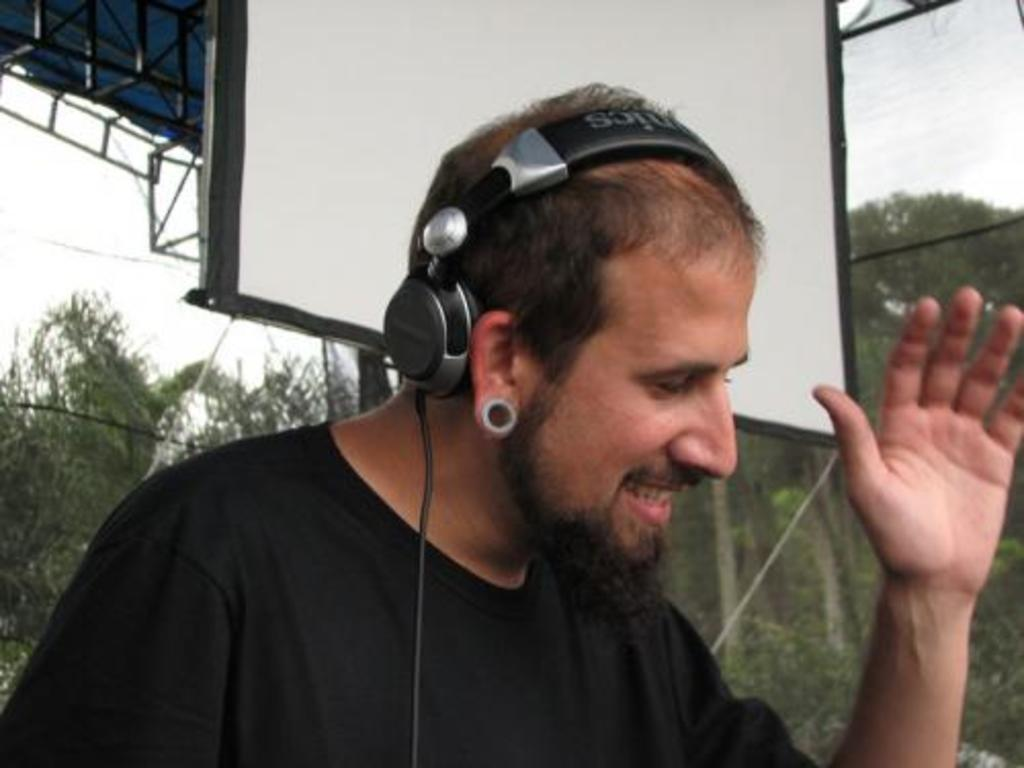What is the man in the image doing? The man is standing in the image. What is the man wearing on his upper body? The man is wearing a black shirt. What is the man wearing on his ears? The man is wearing headphones. What type of natural environment can be seen in the image? Trees and the sky are visible in the image. What type of nerve can be seen in the image? There is no nerve visible in the image. How many ducks are present in the image? There are no ducks present in the image. 